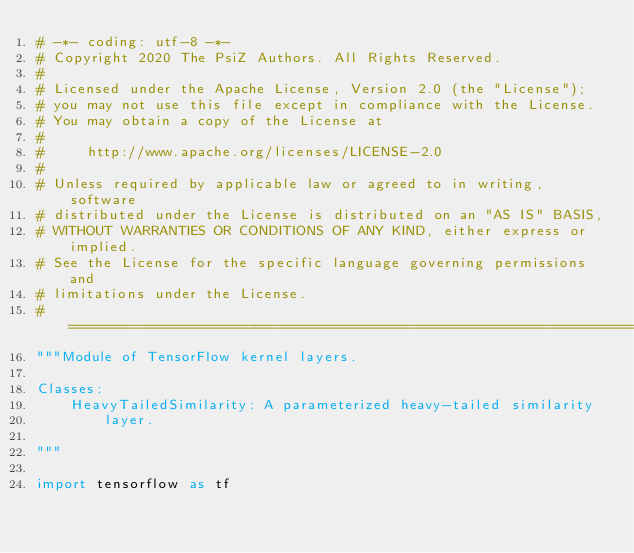<code> <loc_0><loc_0><loc_500><loc_500><_Python_># -*- coding: utf-8 -*-
# Copyright 2020 The PsiZ Authors. All Rights Reserved.
#
# Licensed under the Apache License, Version 2.0 (the "License");
# you may not use this file except in compliance with the License.
# You may obtain a copy of the License at
#
#     http://www.apache.org/licenses/LICENSE-2.0
#
# Unless required by applicable law or agreed to in writing, software
# distributed under the License is distributed on an "AS IS" BASIS,
# WITHOUT WARRANTIES OR CONDITIONS OF ANY KIND, either express or implied.
# See the License for the specific language governing permissions and
# limitations under the License.
# ============================================================================
"""Module of TensorFlow kernel layers.

Classes:
    HeavyTailedSimilarity: A parameterized heavy-tailed similarity
        layer.

"""

import tensorflow as tf</code> 